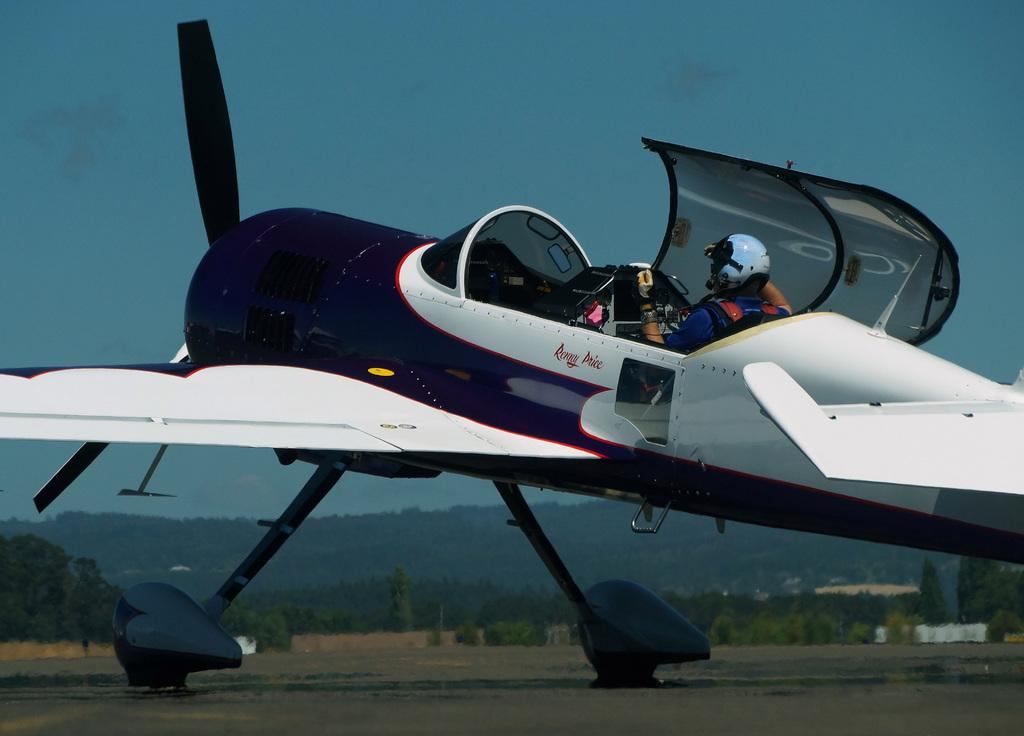What is happening in the image? There is a flight in the image, and a person is riding it. What can be seen through the open window of the flight? The window of the flight is open, but the image does not provide a clear view of what is outside. However, we can see that there are trees in the background of the image. What is the person doing while riding the flight? The person is simply riding the flight, as there are no other activities or objects mentioned in the image. What type of question is the person asking while riding the flight in the image? There is no indication in the image that the person is asking a question or engaging in any specific activity besides riding the flight. 